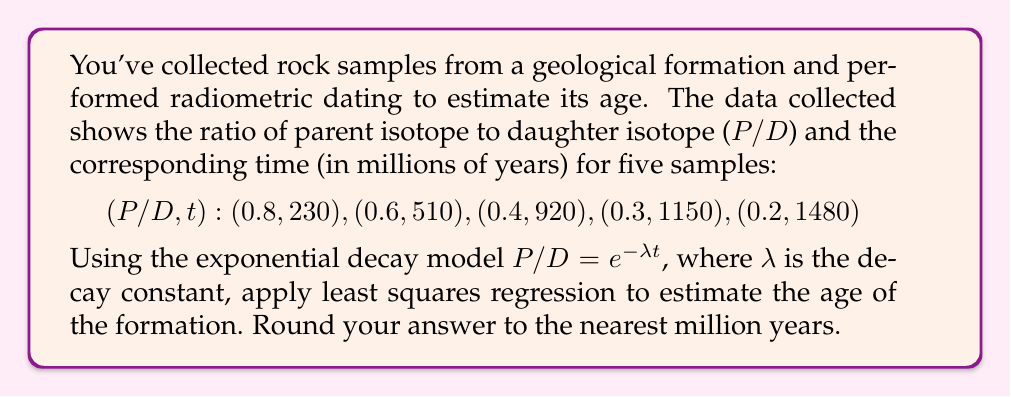Give your solution to this math problem. To solve this problem, we'll follow these steps:

1) First, we need to linearize the exponential model. Taking the natural log of both sides:
   $$\ln(P/D) = -\lambda t$$

2) Let $y = \ln(P/D)$ and $x = t$. Our linear model becomes $y = -\lambda x$.

3) Calculate $\ln(P/D)$ for each data point:
   $$(x, y): (230, -0.223), (510, -0.511), (920, -0.916), (1150, -1.204), (1480, -1.609)$$

4) Use the least squares formula to find the slope $m$ (which equals $-\lambda$):
   $$m = \frac{n\sum xy - \sum x \sum y}{n\sum x^2 - (\sum x)^2}$$

   Where $n = 5$ (number of data points)

5) Calculate the sums:
   $\sum x = 4290$
   $\sum y = -4.463$
   $\sum xy = -4136.919$
   $\sum x^2 = 4,453,700$

6) Plug into the formula:
   $$m = \frac{5(-4136.919) - (4290)(-4.463)}{5(4,453,700) - (4290)^2} = -0.001083$$

7) Therefore, $\lambda = 0.001083$

8) The half-life $t_{1/2}$ is related to $\lambda$ by:
   $$t_{1/2} = \frac{\ln(2)}{\lambda} = \frac{0.693}{0.001083} = 640 \text{ million years}$$

9) To estimate the age of the formation, we typically use 5-6 half-lives. Let's use 5.5:
   $$\text{Age} = 5.5 \times 640 = 3520 \text{ million years}$$

Rounding to the nearest million years gives us 3520 million years.
Answer: 3520 million years 